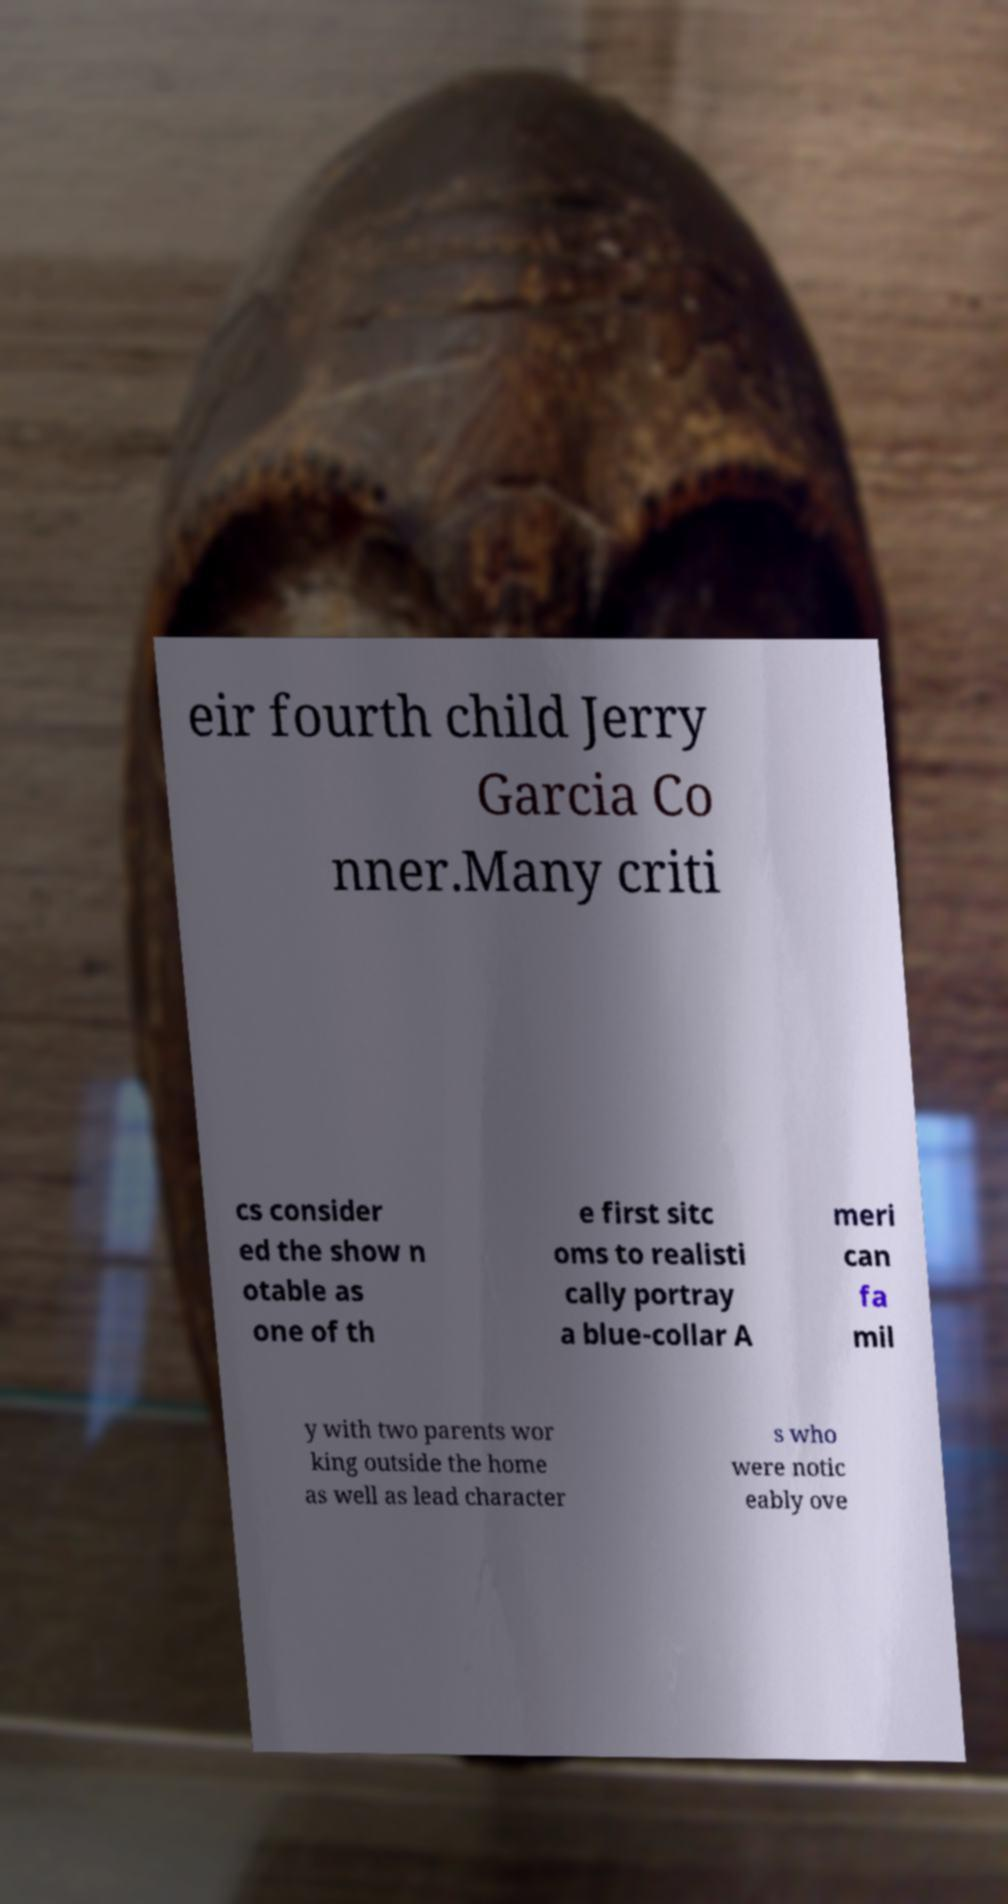There's text embedded in this image that I need extracted. Can you transcribe it verbatim? eir fourth child Jerry Garcia Co nner.Many criti cs consider ed the show n otable as one of th e first sitc oms to realisti cally portray a blue-collar A meri can fa mil y with two parents wor king outside the home as well as lead character s who were notic eably ove 